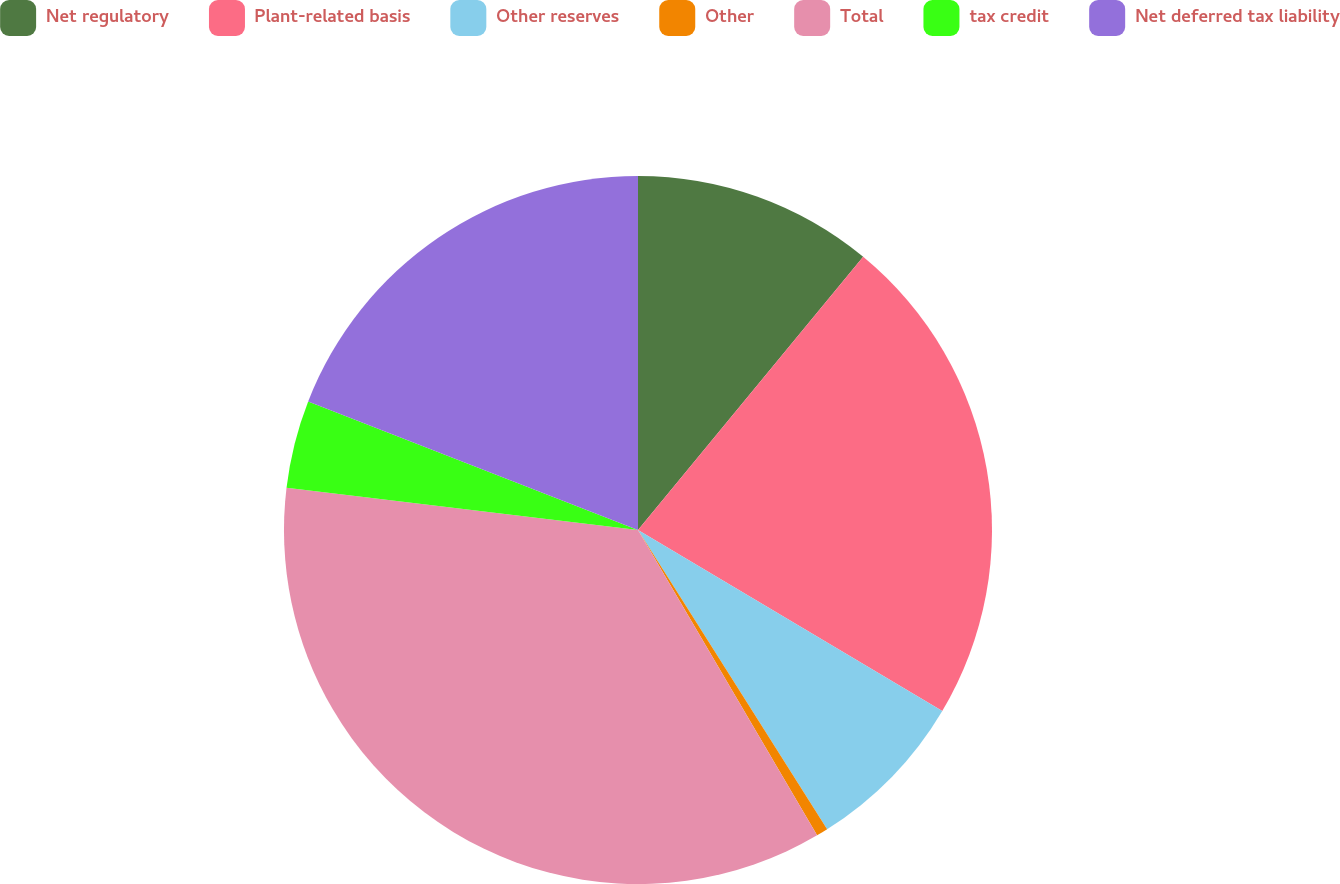Convert chart. <chart><loc_0><loc_0><loc_500><loc_500><pie_chart><fcel>Net regulatory<fcel>Plant-related basis<fcel>Other reserves<fcel>Other<fcel>Total<fcel>tax credit<fcel>Net deferred tax liability<nl><fcel>10.97%<fcel>22.56%<fcel>7.49%<fcel>0.53%<fcel>35.34%<fcel>4.01%<fcel>19.08%<nl></chart> 